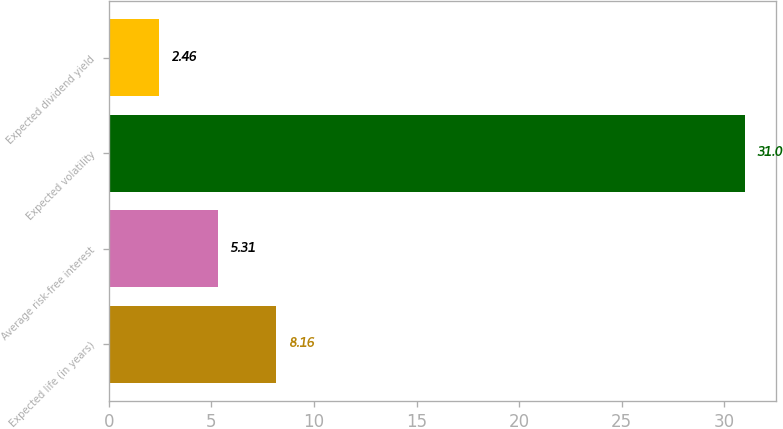Convert chart. <chart><loc_0><loc_0><loc_500><loc_500><bar_chart><fcel>Expected life (in years)<fcel>Average risk-free interest<fcel>Expected volatility<fcel>Expected dividend yield<nl><fcel>8.16<fcel>5.31<fcel>31<fcel>2.46<nl></chart> 